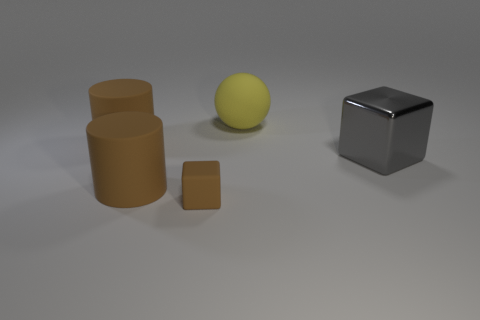Add 1 blocks. How many objects exist? 6 Subtract all cylinders. How many objects are left? 3 Subtract all cyan shiny cylinders. Subtract all brown cubes. How many objects are left? 4 Add 2 large spheres. How many large spheres are left? 3 Add 1 tiny gray spheres. How many tiny gray spheres exist? 1 Subtract 0 green balls. How many objects are left? 5 